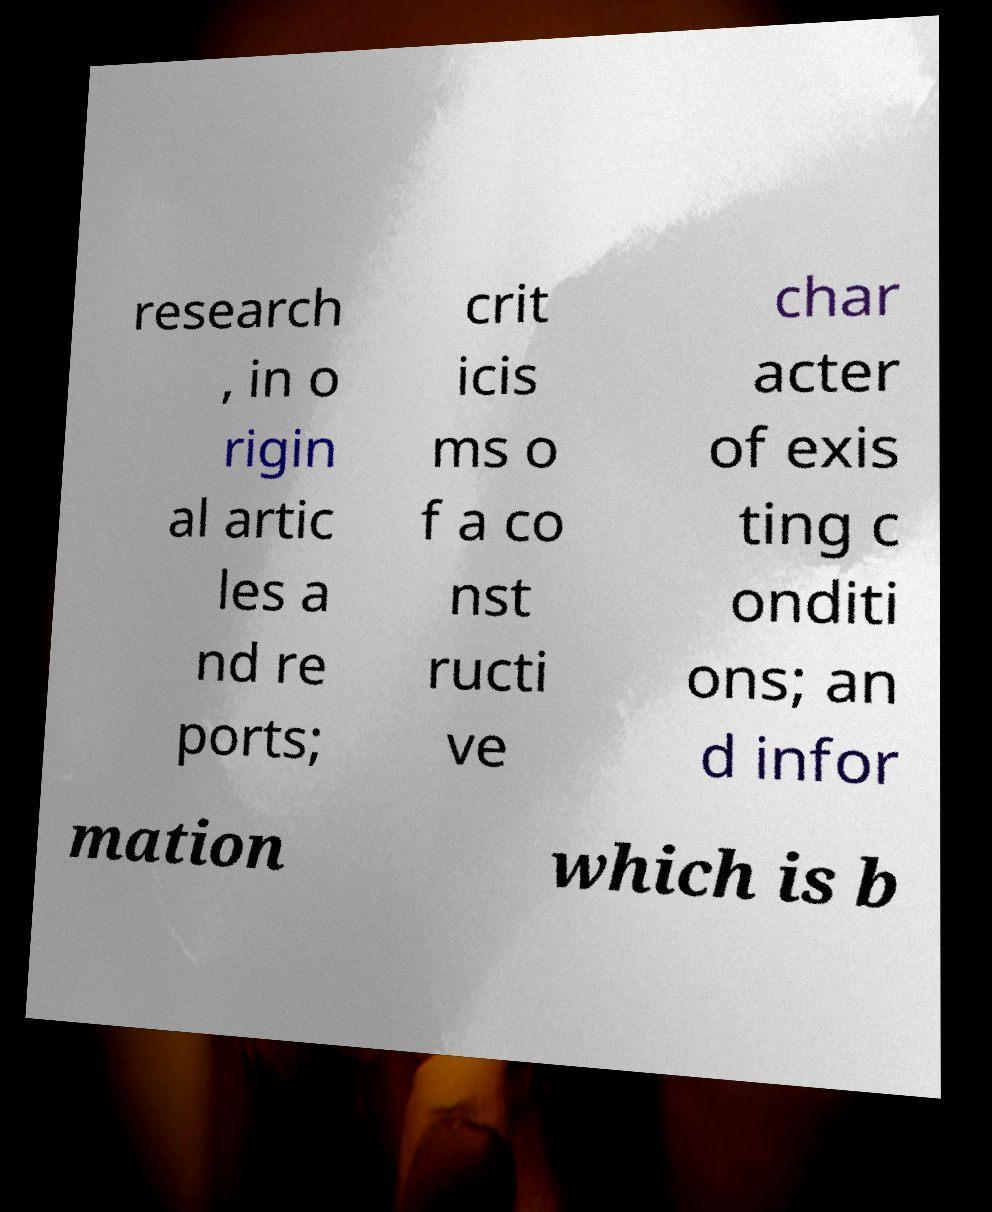Can you accurately transcribe the text from the provided image for me? research , in o rigin al artic les a nd re ports; crit icis ms o f a co nst ructi ve char acter of exis ting c onditi ons; an d infor mation which is b 